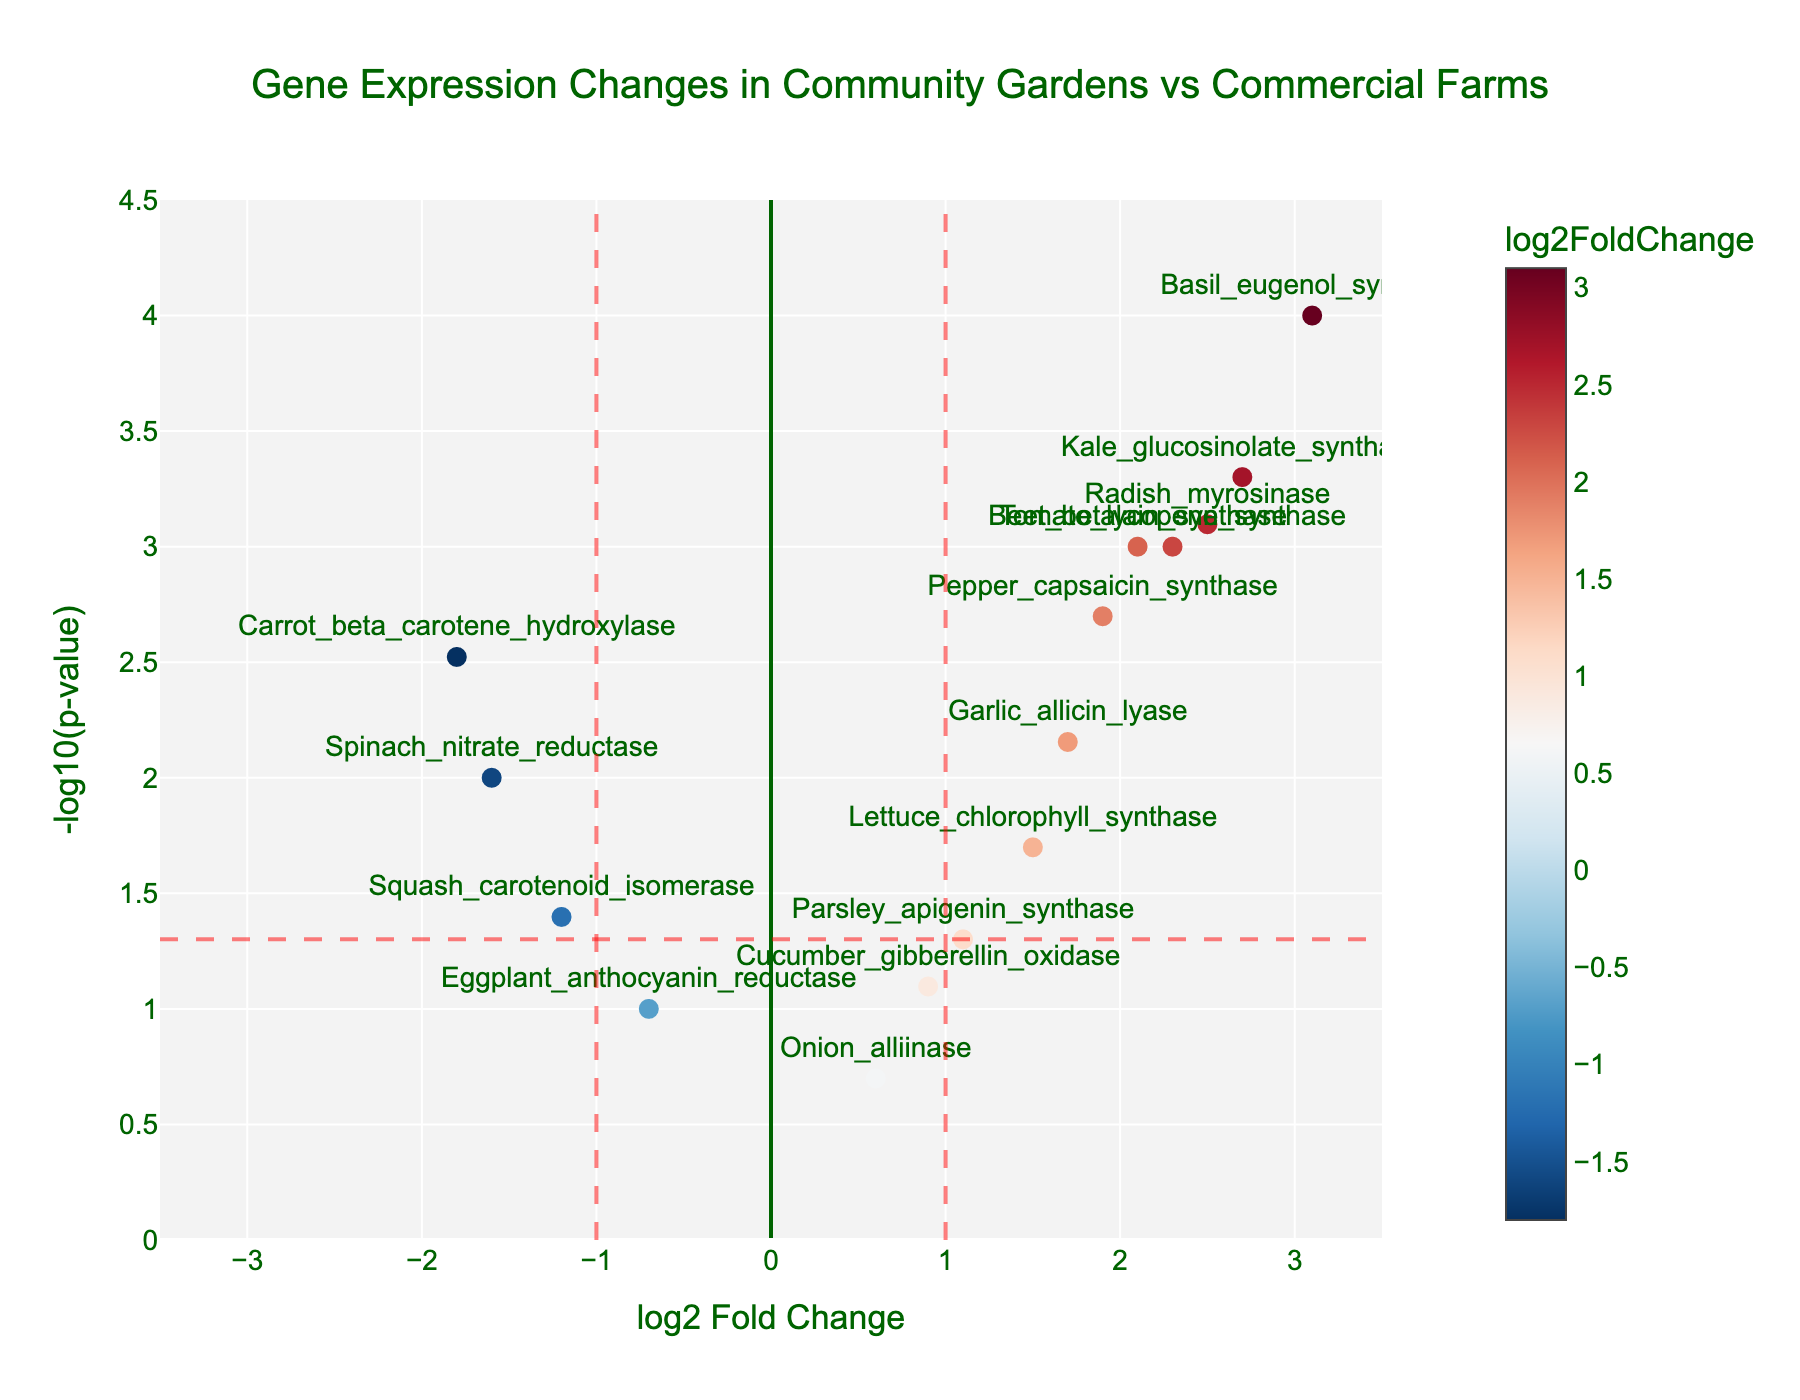How many genes have a log2 fold change (log2FC) greater than 1? First, look at the x-axis to identify genes with a log2FC greater than 1. By counting each data point to the right of the vertical threshold line at log2FC = 1, you find there are four points.
Answer: 4 Which gene has the most significant p-value on the plot? The most significant p-value corresponds to the highest -log10(p-value) on the y-axis. The gene that appears highest on the plot is Basil_eugenol_synthase.
Answer: Basil_eugenol_synthase Are there more upregulated or downregulated genes with a significant p-value (below 0.05)? Upregulated genes have log2FC > 0, while downregulated ones have log2FC < 0. Count the points meeting these criteria with -log10(p-value) > 1.3 (corresponding to p < 0.05). There are more upregulated genes.
Answer: Upregulated What is the purpose of the horizontal and vertical dashed lines on the plot? The horizontal dashed line at -log10(p-value) = 1.3 represents the significance threshold (p-value = 0.05). The vertical lines at log2FC = ±1 indicate the threshold for biologically meaningful change. These lines help identify genes with both significant and meaningful expression changes.
Answer: Thresholds for significance and meaningful change Which gene shows the highest log2 fold change on the plot? The highest log2FC corresponds to the right-most point on the x-axis. This gene is Basil_eugenol_synthase, with the highest positive change.
Answer: Basil_eugenol_synthase Is there a correlation between the log2 fold change and -log10(p-value) in the plot? By visually examining the scatter plot, there does not appear to be a direct correlation between log2 fold change and -log10(p-value), as they seem randomly distributed rather than forming a clear pattern.
Answer: No What is the range of -log10(p-value) represented on the y-axis? The y-axis ranges from 0 to 4.5, showing the variation in -log10(p-value) values for the data points.
Answer: 0 to 4.5 